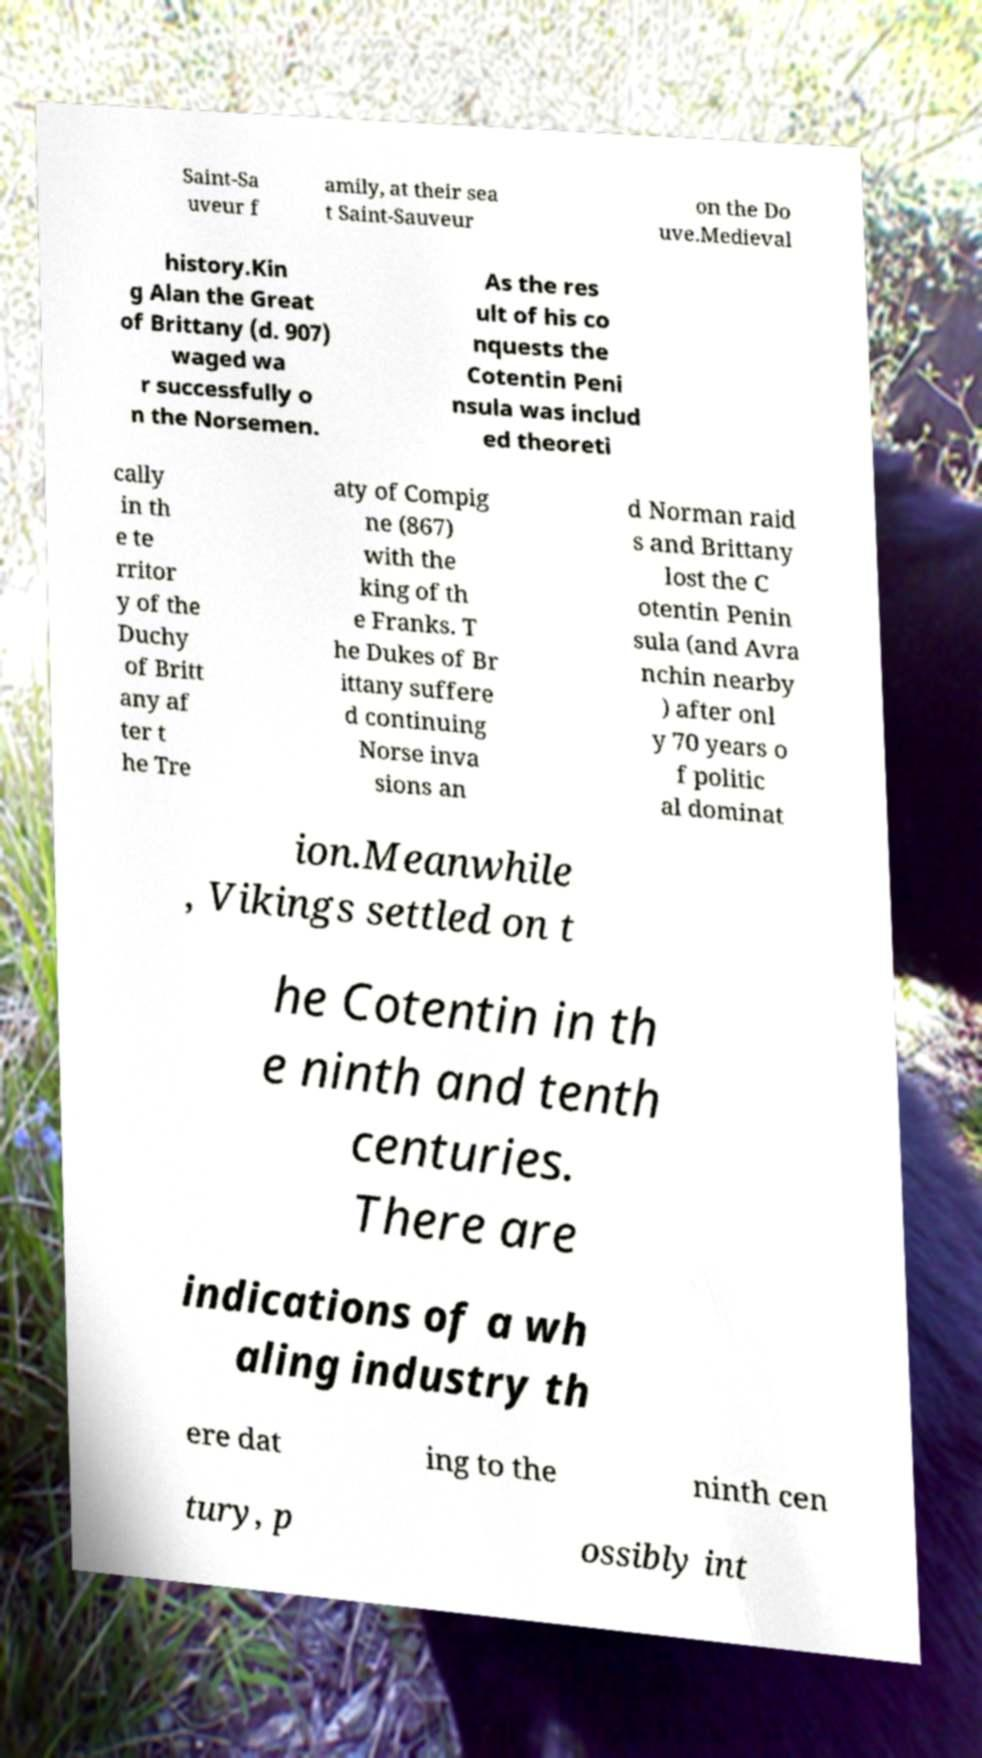Can you accurately transcribe the text from the provided image for me? Saint-Sa uveur f amily, at their sea t Saint-Sauveur on the Do uve.Medieval history.Kin g Alan the Great of Brittany (d. 907) waged wa r successfully o n the Norsemen. As the res ult of his co nquests the Cotentin Peni nsula was includ ed theoreti cally in th e te rritor y of the Duchy of Britt any af ter t he Tre aty of Compig ne (867) with the king of th e Franks. T he Dukes of Br ittany suffere d continuing Norse inva sions an d Norman raid s and Brittany lost the C otentin Penin sula (and Avra nchin nearby ) after onl y 70 years o f politic al dominat ion.Meanwhile , Vikings settled on t he Cotentin in th e ninth and tenth centuries. There are indications of a wh aling industry th ere dat ing to the ninth cen tury, p ossibly int 